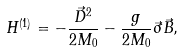Convert formula to latex. <formula><loc_0><loc_0><loc_500><loc_500>H ^ { ( 1 ) } = - \frac { \vec { D } ^ { 2 } } { 2 M _ { 0 } } - \frac { g } { 2 M _ { 0 } } \vec { \sigma } \vec { B } ,</formula> 